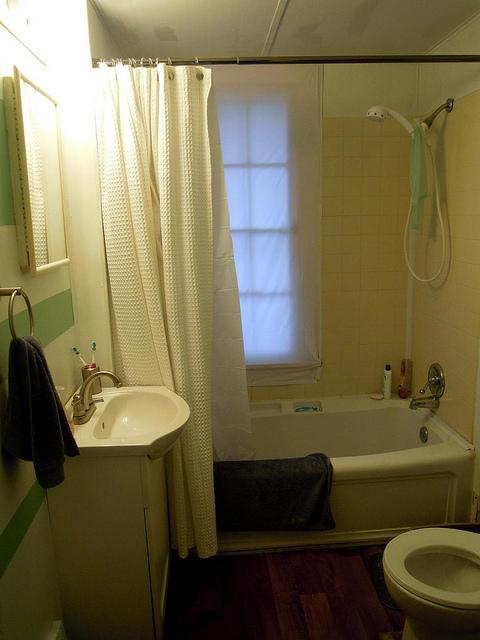What color are the stripes on the side of the bathroom wall?

Choices:
A) blue
B) purple
C) green
D) pink green 